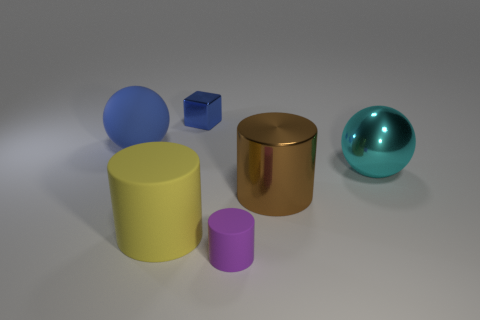What is the color of the tiny matte object?
Your response must be concise. Purple. Is there any other thing that has the same color as the tiny metallic thing?
Keep it short and to the point. Yes. What is the color of the thing that is behind the large brown metal cylinder and on the right side of the purple matte cylinder?
Make the answer very short. Cyan. Does the ball on the right side of the brown metallic thing have the same size as the yellow thing?
Offer a very short reply. Yes. Are there more small purple matte things that are behind the cube than large green metallic balls?
Your response must be concise. No. Is the blue metal thing the same shape as the blue rubber object?
Your answer should be compact. No. How big is the brown metallic cylinder?
Your answer should be compact. Large. Is the number of tiny objects that are on the right side of the small cylinder greater than the number of brown metallic objects that are to the left of the big brown object?
Offer a terse response. No. There is a tiny purple rubber cylinder; are there any large rubber spheres in front of it?
Ensure brevity in your answer.  No. Are there any red things of the same size as the cyan metallic thing?
Make the answer very short. No. 